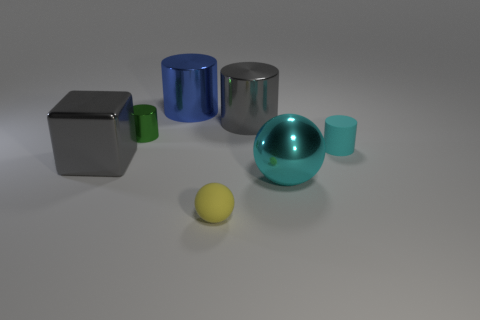Add 1 metal cylinders. How many objects exist? 8 Subtract all spheres. How many objects are left? 5 Subtract all small red cylinders. Subtract all tiny cyan objects. How many objects are left? 6 Add 4 small metal objects. How many small metal objects are left? 5 Add 5 gray metallic objects. How many gray metallic objects exist? 7 Subtract 0 purple balls. How many objects are left? 7 